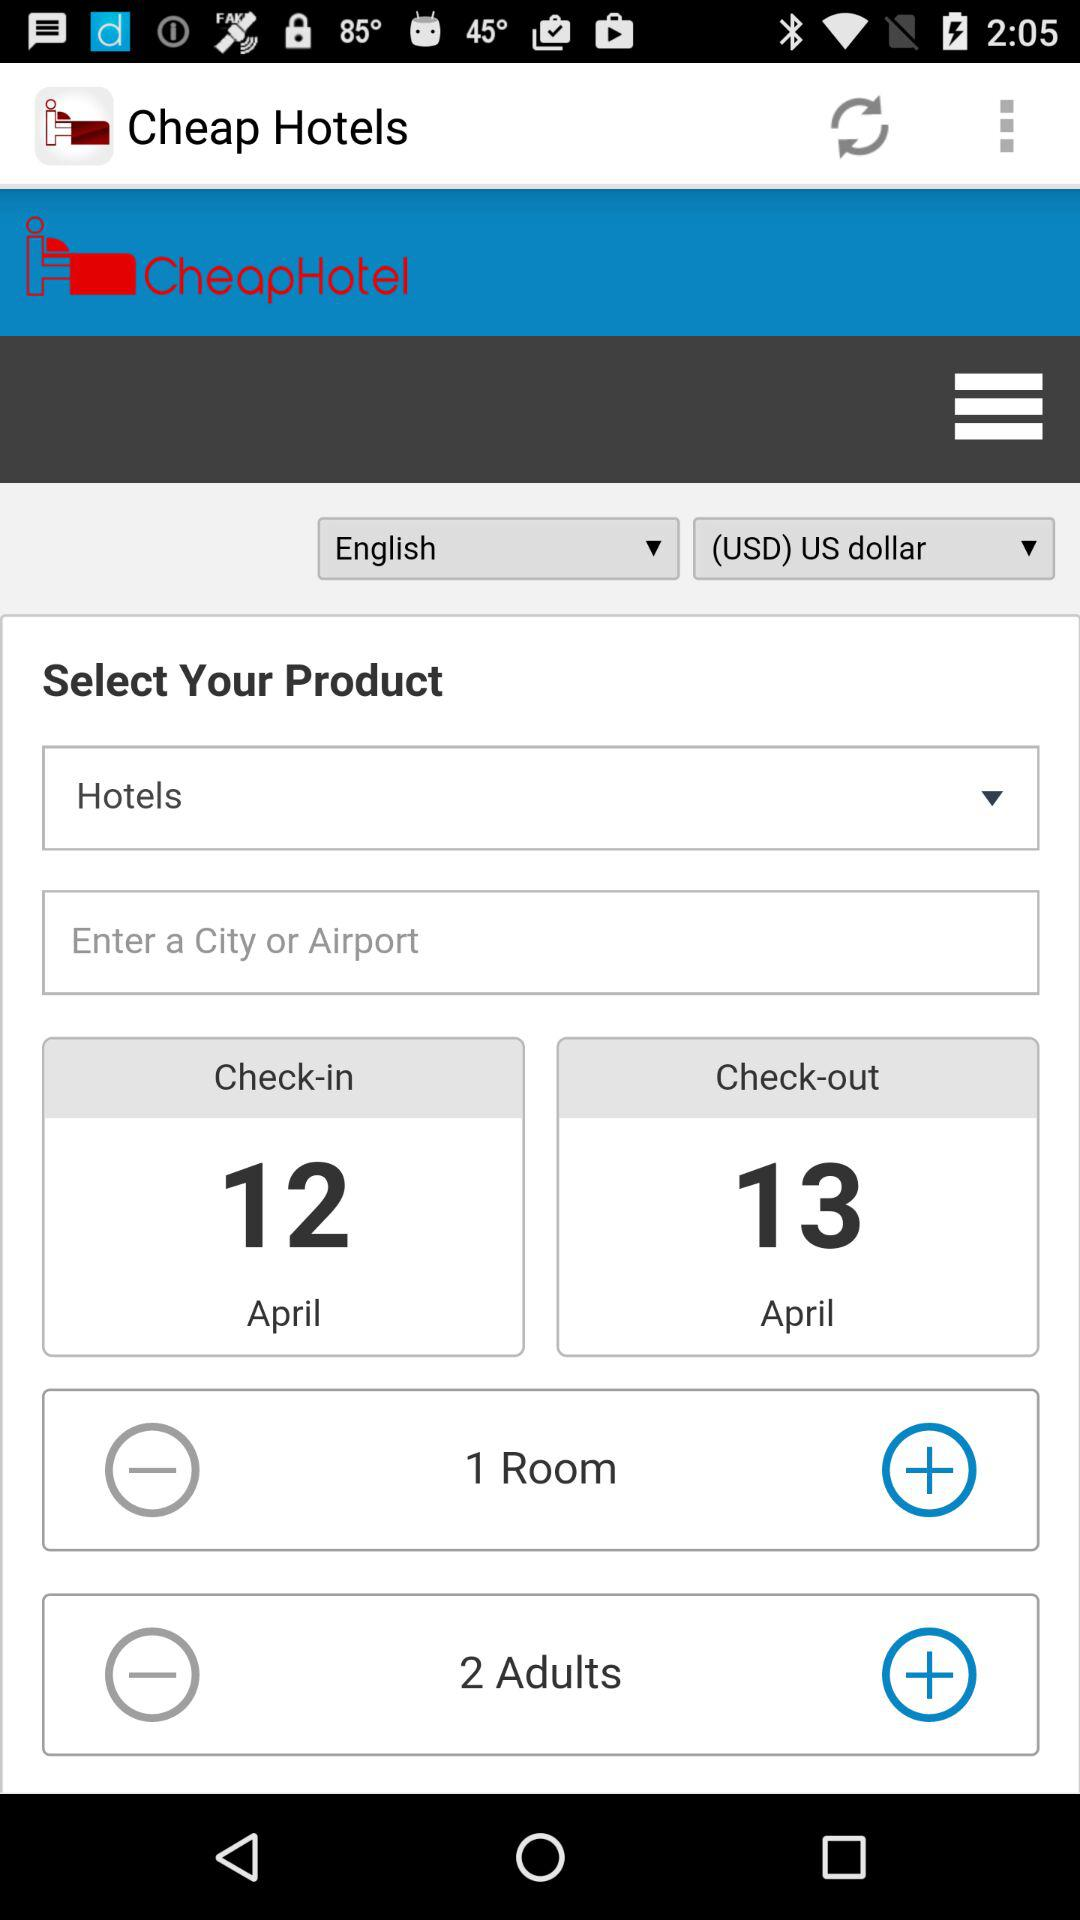How many days are there between the check-in and check-out dates?
Answer the question using a single word or phrase. 1 